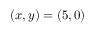Convert formula to latex. <formula><loc_0><loc_0><loc_500><loc_500>( x , y ) = ( 5 , 0 )</formula> 